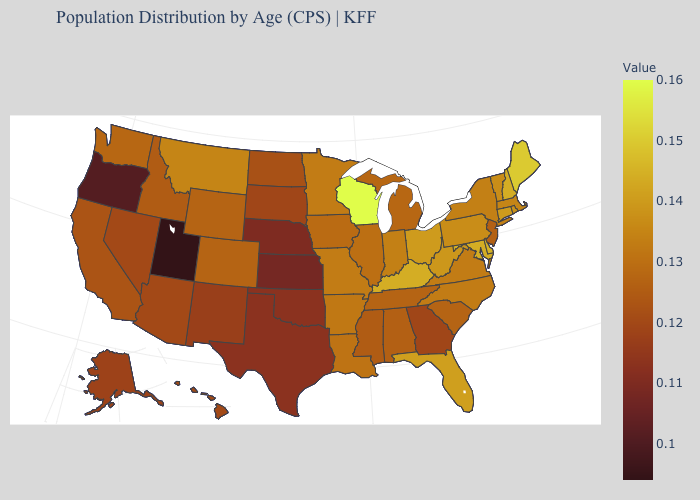Does Alabama have a higher value than Oklahoma?
Quick response, please. Yes. Among the states that border Montana , which have the highest value?
Keep it brief. Wyoming. Which states have the lowest value in the South?
Answer briefly. Oklahoma, Texas. Is the legend a continuous bar?
Quick response, please. Yes. 